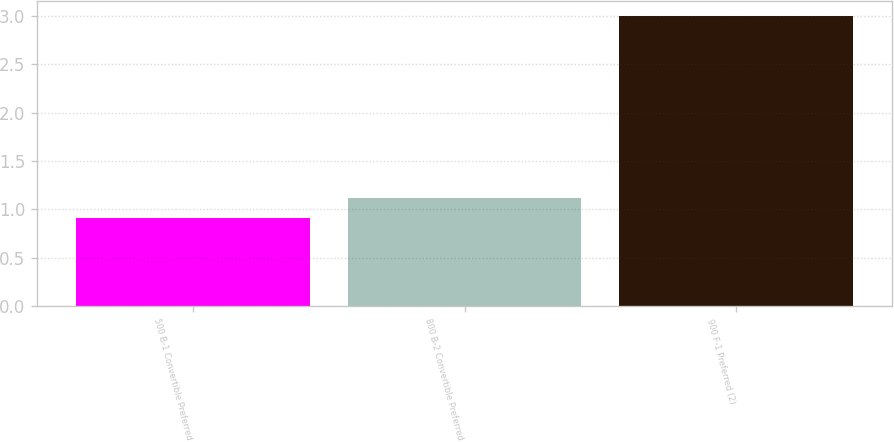Convert chart. <chart><loc_0><loc_0><loc_500><loc_500><bar_chart><fcel>500 B-1 Convertible Preferred<fcel>800 B-2 Convertible Preferred<fcel>900 F-1 Preferred (2)<nl><fcel>0.91<fcel>1.12<fcel>3<nl></chart> 